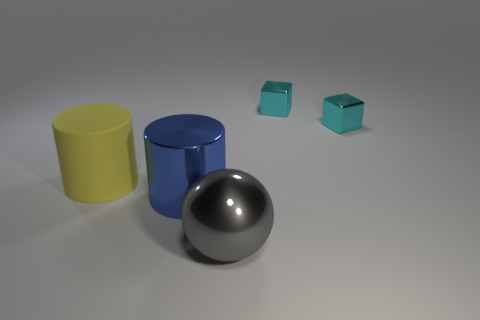Add 4 large red matte objects. How many objects exist? 9 Subtract all cylinders. How many objects are left? 3 Add 5 big gray objects. How many big gray objects are left? 6 Add 3 yellow objects. How many yellow objects exist? 4 Subtract 0 red cubes. How many objects are left? 5 Subtract all blue metallic cylinders. Subtract all small cyan shiny cubes. How many objects are left? 2 